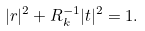Convert formula to latex. <formula><loc_0><loc_0><loc_500><loc_500>| r | ^ { 2 } + R _ { k } ^ { - 1 } | t | ^ { 2 } = 1 .</formula> 